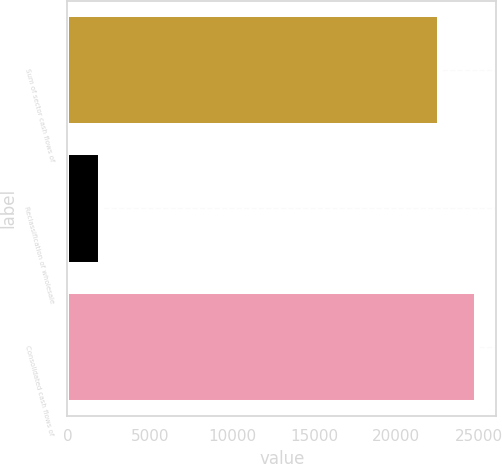Convert chart to OTSL. <chart><loc_0><loc_0><loc_500><loc_500><bar_chart><fcel>Sum of sector cash flows of<fcel>Reclassification of wholesale<fcel>Consolidated cash flows of<nl><fcel>22561<fcel>2001<fcel>24817.1<nl></chart> 